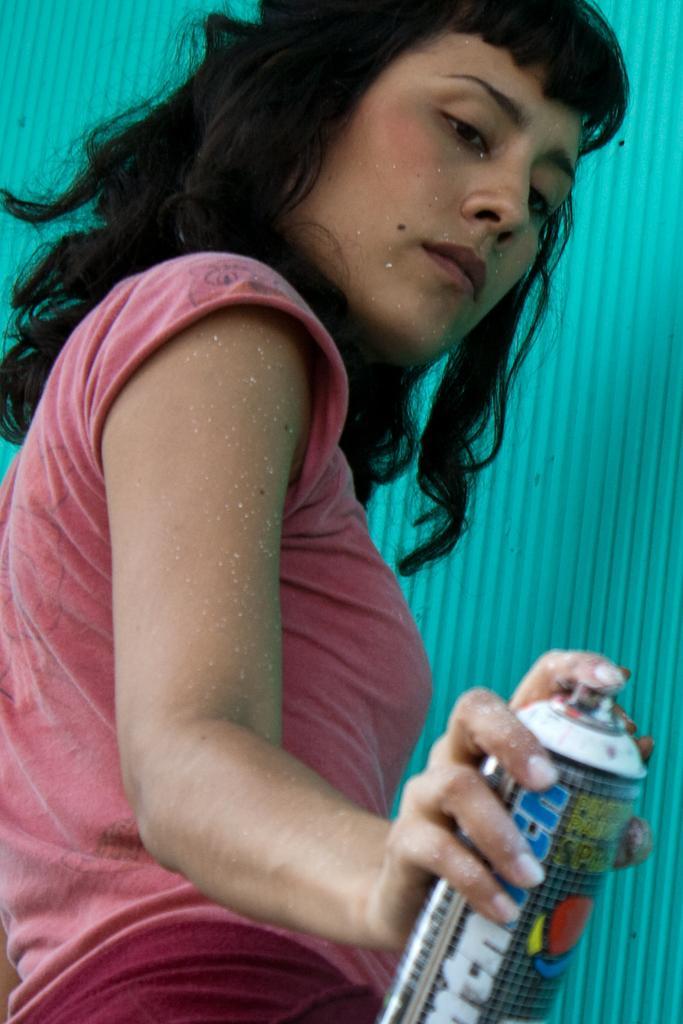Describe this image in one or two sentences. In this picture I can see a woman holding a bottle. 